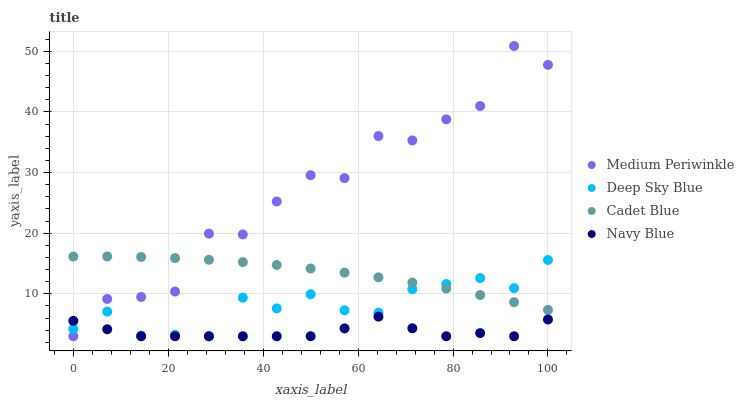Does Navy Blue have the minimum area under the curve?
Answer yes or no. Yes. Does Medium Periwinkle have the maximum area under the curve?
Answer yes or no. Yes. Does Cadet Blue have the minimum area under the curve?
Answer yes or no. No. Does Cadet Blue have the maximum area under the curve?
Answer yes or no. No. Is Cadet Blue the smoothest?
Answer yes or no. Yes. Is Medium Periwinkle the roughest?
Answer yes or no. Yes. Is Medium Periwinkle the smoothest?
Answer yes or no. No. Is Cadet Blue the roughest?
Answer yes or no. No. Does Navy Blue have the lowest value?
Answer yes or no. Yes. Does Cadet Blue have the lowest value?
Answer yes or no. No. Does Medium Periwinkle have the highest value?
Answer yes or no. Yes. Does Cadet Blue have the highest value?
Answer yes or no. No. Is Navy Blue less than Cadet Blue?
Answer yes or no. Yes. Is Cadet Blue greater than Navy Blue?
Answer yes or no. Yes. Does Navy Blue intersect Deep Sky Blue?
Answer yes or no. Yes. Is Navy Blue less than Deep Sky Blue?
Answer yes or no. No. Is Navy Blue greater than Deep Sky Blue?
Answer yes or no. No. Does Navy Blue intersect Cadet Blue?
Answer yes or no. No. 